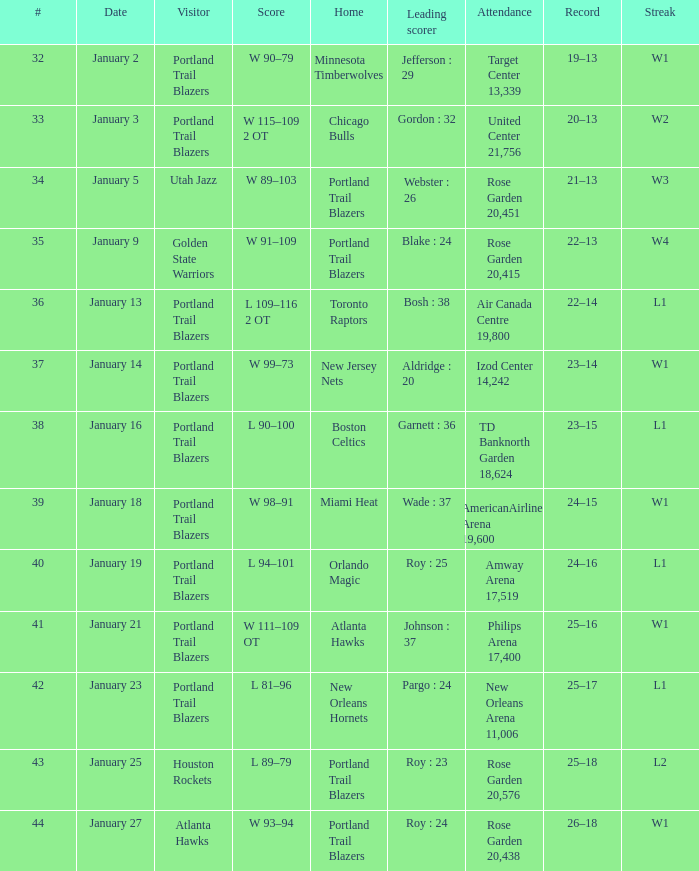What are all the records with a score is w 98–91 24–15. 